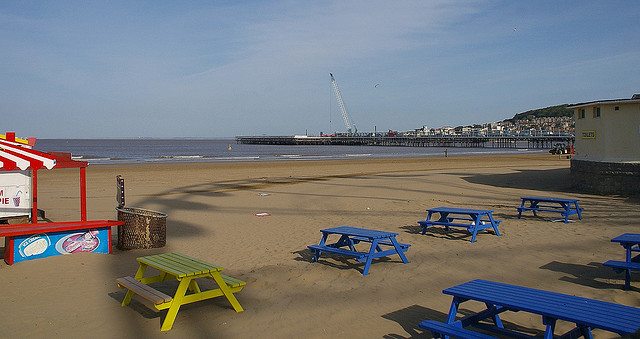<image>What is the name of the ship these people are on? There is no ship in the image. What is the name of the ship these people are on? The name of the ship these people are on is not mentioned or visible in the image. 